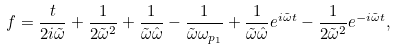<formula> <loc_0><loc_0><loc_500><loc_500>f = \frac { t } { 2 i \tilde { \omega } } + \frac { 1 } { 2 \tilde { \omega } ^ { 2 } } + \frac { 1 } { \tilde { \omega } \hat { \omega } } - \frac { 1 } { \tilde { \omega } \omega _ { p _ { 1 } } } + \frac { 1 } { \tilde { \omega } \hat { \omega } } e ^ { i \tilde { \omega } t } - \frac { 1 } { 2 \tilde { \omega } ^ { 2 } } e ^ { - i \tilde { \omega } t } ,</formula> 